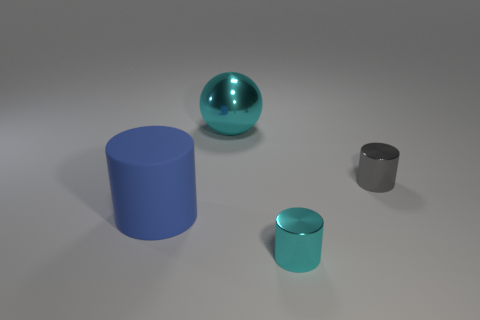There is a tiny cylinder that is the same color as the metal sphere; what is it made of?
Your response must be concise. Metal. The cylinder that is the same color as the large ball is what size?
Make the answer very short. Small. There is a small object behind the tiny cyan metal cylinder that is to the right of the cyan shiny sphere; what is its color?
Make the answer very short. Gray. Is the cyan cylinder made of the same material as the blue cylinder?
Offer a very short reply. No. Are there any gray things that have the same shape as the blue thing?
Your response must be concise. Yes. There is a large object that is in front of the large sphere; does it have the same color as the large metal thing?
Make the answer very short. No. Do the cyan thing in front of the large shiny sphere and the cyan metal object that is behind the gray metallic cylinder have the same size?
Offer a terse response. No. What size is the cyan ball that is made of the same material as the small gray thing?
Make the answer very short. Large. How many objects are both behind the large rubber object and right of the ball?
Offer a terse response. 1. How many things are either tiny yellow metal cylinders or metallic things that are on the right side of the large cyan shiny object?
Provide a short and direct response. 2. 